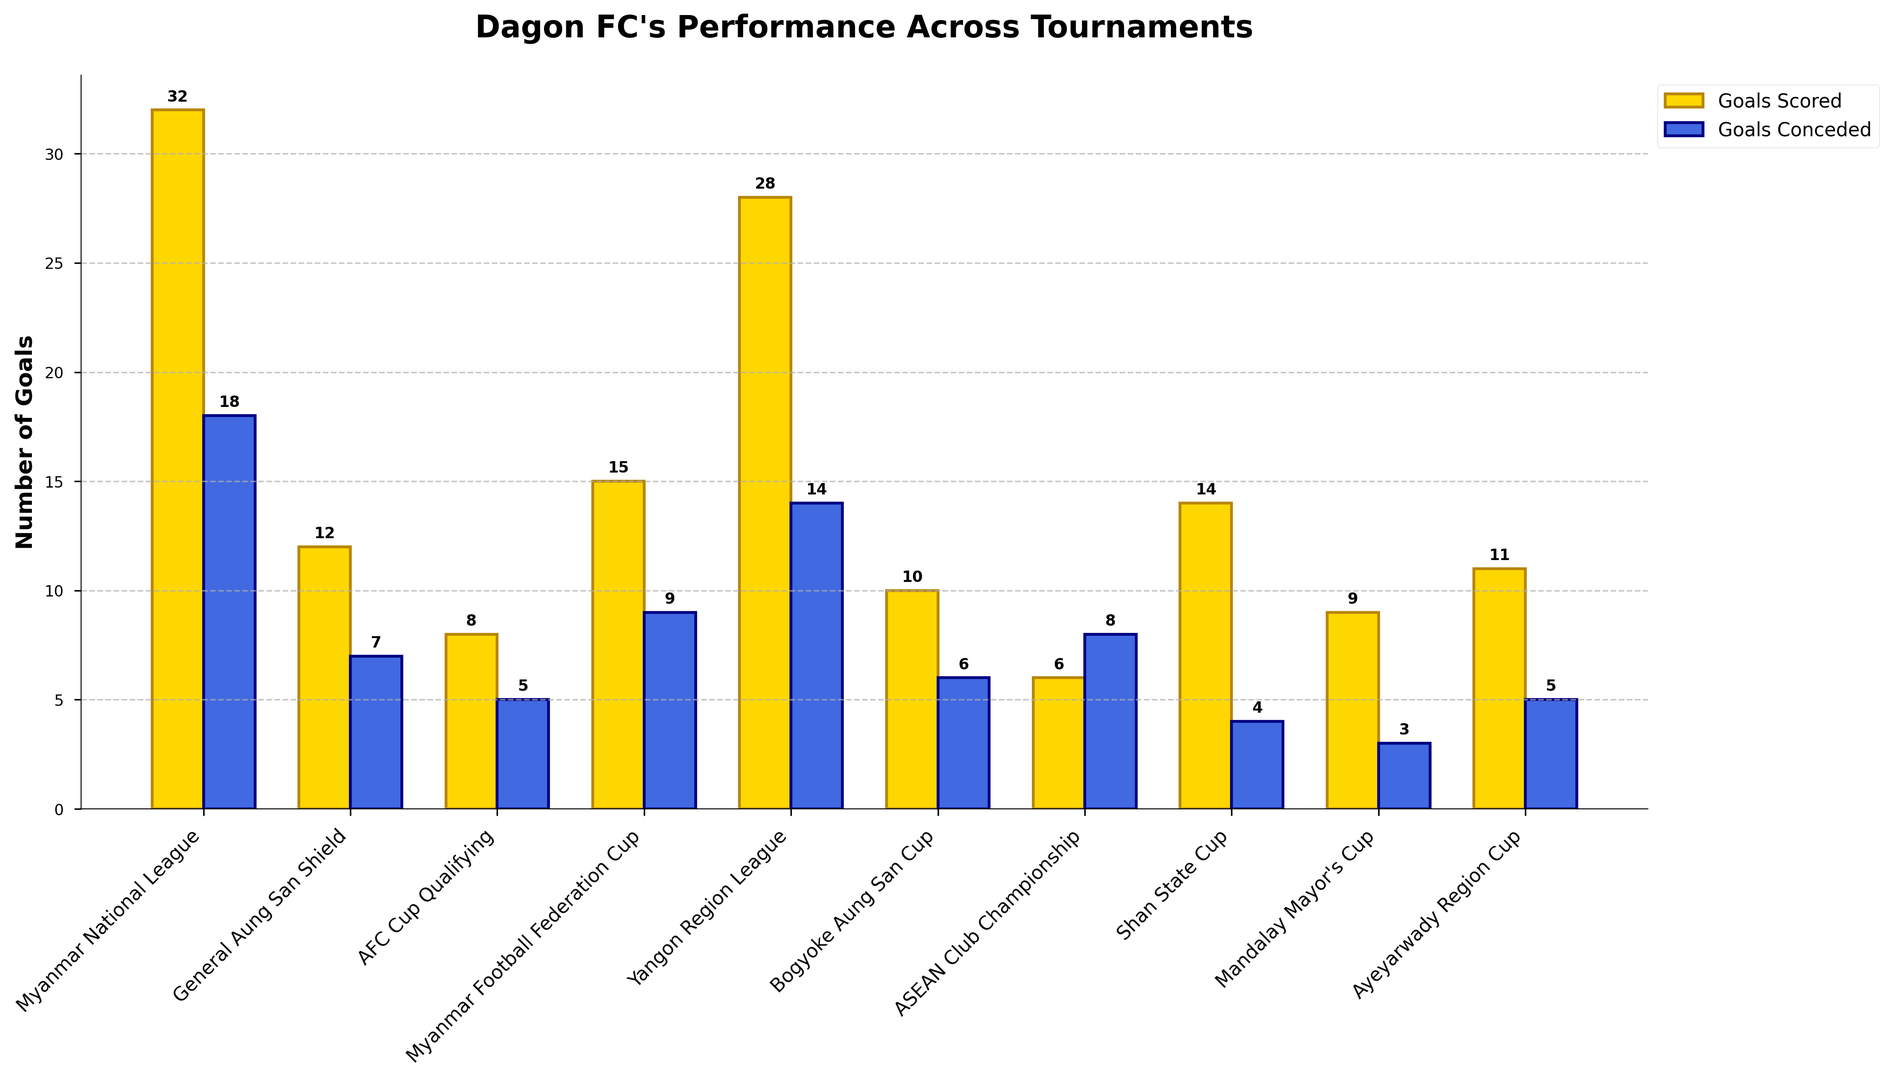What is the total number of goals scored by Dagon FC in the Myanmar National League and the Yangon Region League combined? The number of goals scored in the Myanmar National League is 32, and in the Yangon Region League is 28. The sum is 32 + 28 = 60.
Answer: 60 Which tournament shows a higher number of goals conceded, the AFC Cup Qualifying or the ASEAN Club Championship? The AFC Cup Qualifying has 5 goals conceded, while the ASEAN Club Championship has 8 goals conceded. Comparing the two values, 8 > 5.
Answer: ASEAN Club Championship In which tournament did Dagon FC score more goals, the General Aung San Shield or the Bogyoke Aung San Cup? The General Aung San Shield has 12 goals scored, and the Bogyoke Aung San Cup has 10 goals scored. Comparing the two values, 12 > 10.
Answer: General Aung San Shield What is the visual difference in height between the bars representing goals scored and goals conceded in the Mandalay Mayor's Cup? The goals scored bar is taller than the goals conceded bar in the Mandalay Mayor's Cup. Goals scored = 9, Goals conceded = 3.
Answer: Goals scored bar is taller Is there any tournament where the number of goals scored is equal to the number of goals conceded? To answer, we need to compare goals scored vs. goals conceded for each tournament. None have goals scored = goals conceded across different tournaments.
Answer: No By how many goals does the number of goals scored in the Shan State Cup exceed the number of goals conceded in the same tournament? Goals scored in the Shan State Cup = 14, Goals conceded = 4. The difference is 14 - 4 = 10.
Answer: 10 What is the average number of goals scored by Dagon FC across all tournaments? Sum of goals scored across all tournaments = 32 + 12 + 8 + 15 + 28 + 10 + 6 + 14 + 9 + 11 = 145. There are 10 tournaments, so the average is 145 / 10 = 14.5.
Answer: 14.5 